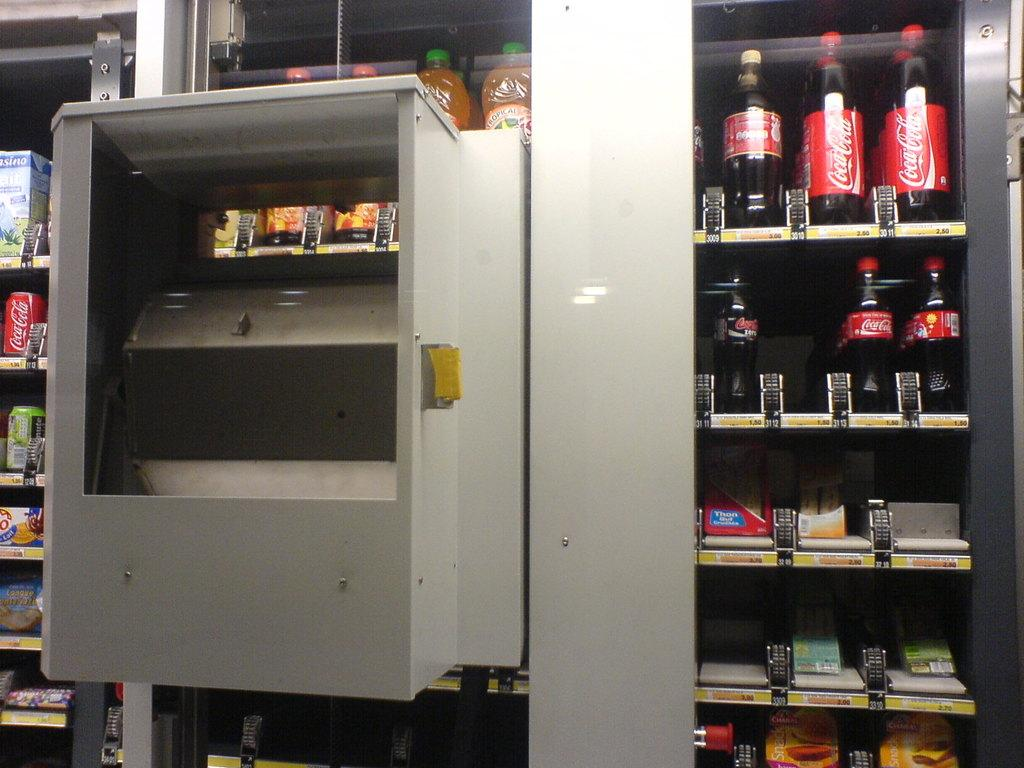<image>
Write a terse but informative summary of the picture. A few Coca-cola bottles line the shelves of a vending machine. 